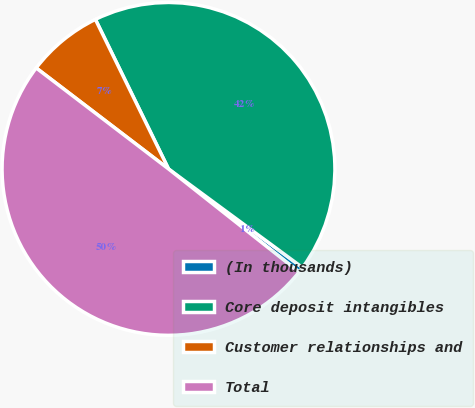Convert chart to OTSL. <chart><loc_0><loc_0><loc_500><loc_500><pie_chart><fcel>(In thousands)<fcel>Core deposit intangibles<fcel>Customer relationships and<fcel>Total<nl><fcel>0.54%<fcel>42.34%<fcel>7.39%<fcel>49.73%<nl></chart> 